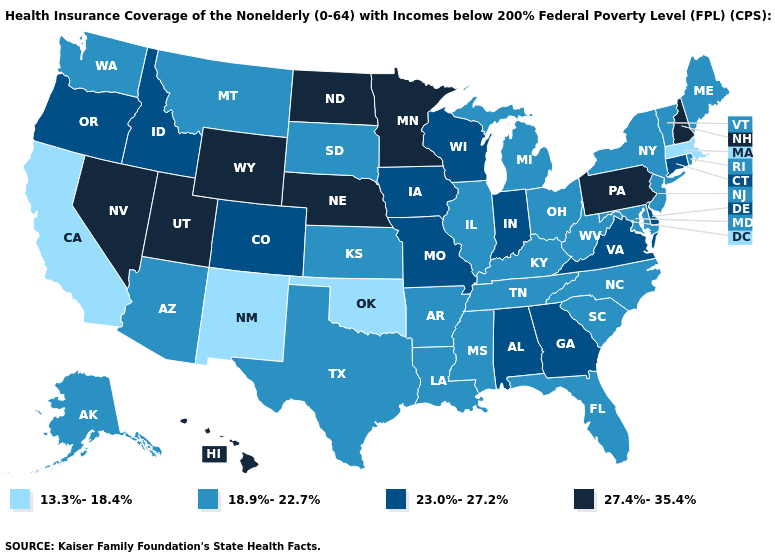Name the states that have a value in the range 13.3%-18.4%?
Concise answer only. California, Massachusetts, New Mexico, Oklahoma. Which states have the lowest value in the South?
Give a very brief answer. Oklahoma. Among the states that border Kansas , does Oklahoma have the highest value?
Quick response, please. No. Name the states that have a value in the range 18.9%-22.7%?
Keep it brief. Alaska, Arizona, Arkansas, Florida, Illinois, Kansas, Kentucky, Louisiana, Maine, Maryland, Michigan, Mississippi, Montana, New Jersey, New York, North Carolina, Ohio, Rhode Island, South Carolina, South Dakota, Tennessee, Texas, Vermont, Washington, West Virginia. Name the states that have a value in the range 13.3%-18.4%?
Answer briefly. California, Massachusetts, New Mexico, Oklahoma. Name the states that have a value in the range 13.3%-18.4%?
Keep it brief. California, Massachusetts, New Mexico, Oklahoma. Which states have the lowest value in the MidWest?
Give a very brief answer. Illinois, Kansas, Michigan, Ohio, South Dakota. Does the map have missing data?
Short answer required. No. Does Montana have the highest value in the USA?
Answer briefly. No. Does Wisconsin have the highest value in the USA?
Be succinct. No. Name the states that have a value in the range 27.4%-35.4%?
Be succinct. Hawaii, Minnesota, Nebraska, Nevada, New Hampshire, North Dakota, Pennsylvania, Utah, Wyoming. Name the states that have a value in the range 27.4%-35.4%?
Keep it brief. Hawaii, Minnesota, Nebraska, Nevada, New Hampshire, North Dakota, Pennsylvania, Utah, Wyoming. Among the states that border New Mexico , which have the highest value?
Short answer required. Utah. Which states hav the highest value in the MidWest?
Write a very short answer. Minnesota, Nebraska, North Dakota. What is the lowest value in states that border Kansas?
Keep it brief. 13.3%-18.4%. 